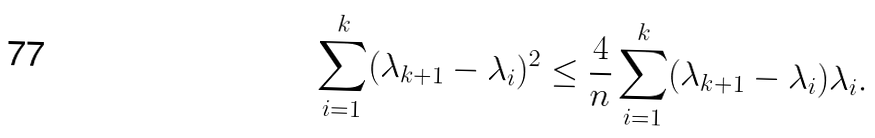<formula> <loc_0><loc_0><loc_500><loc_500>\sum _ { i = 1 } ^ { k } ( \lambda _ { k + 1 } - \lambda _ { i } ) ^ { 2 } \leq \frac { 4 } { n } \sum _ { i = 1 } ^ { k } ( \lambda _ { k + 1 } - \lambda _ { i } ) \lambda _ { i } .</formula> 